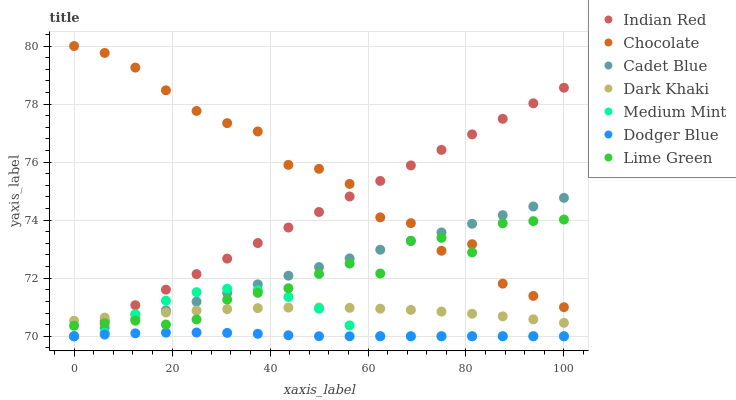Does Dodger Blue have the minimum area under the curve?
Answer yes or no. Yes. Does Chocolate have the maximum area under the curve?
Answer yes or no. Yes. Does Cadet Blue have the minimum area under the curve?
Answer yes or no. No. Does Cadet Blue have the maximum area under the curve?
Answer yes or no. No. Is Cadet Blue the smoothest?
Answer yes or no. Yes. Is Chocolate the roughest?
Answer yes or no. Yes. Is Chocolate the smoothest?
Answer yes or no. No. Is Cadet Blue the roughest?
Answer yes or no. No. Does Medium Mint have the lowest value?
Answer yes or no. Yes. Does Chocolate have the lowest value?
Answer yes or no. No. Does Chocolate have the highest value?
Answer yes or no. Yes. Does Cadet Blue have the highest value?
Answer yes or no. No. Is Medium Mint less than Chocolate?
Answer yes or no. Yes. Is Chocolate greater than Dodger Blue?
Answer yes or no. Yes. Does Dark Khaki intersect Cadet Blue?
Answer yes or no. Yes. Is Dark Khaki less than Cadet Blue?
Answer yes or no. No. Is Dark Khaki greater than Cadet Blue?
Answer yes or no. No. Does Medium Mint intersect Chocolate?
Answer yes or no. No. 